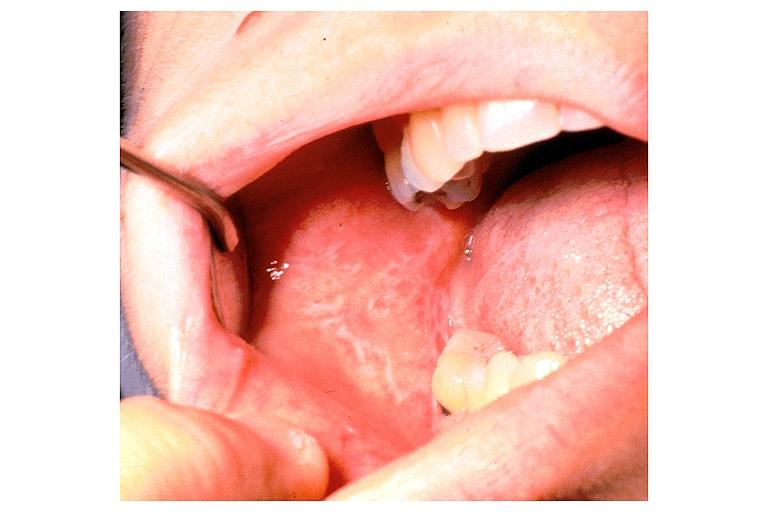what does this image show?
Answer the question using a single word or phrase. Lichen planus 